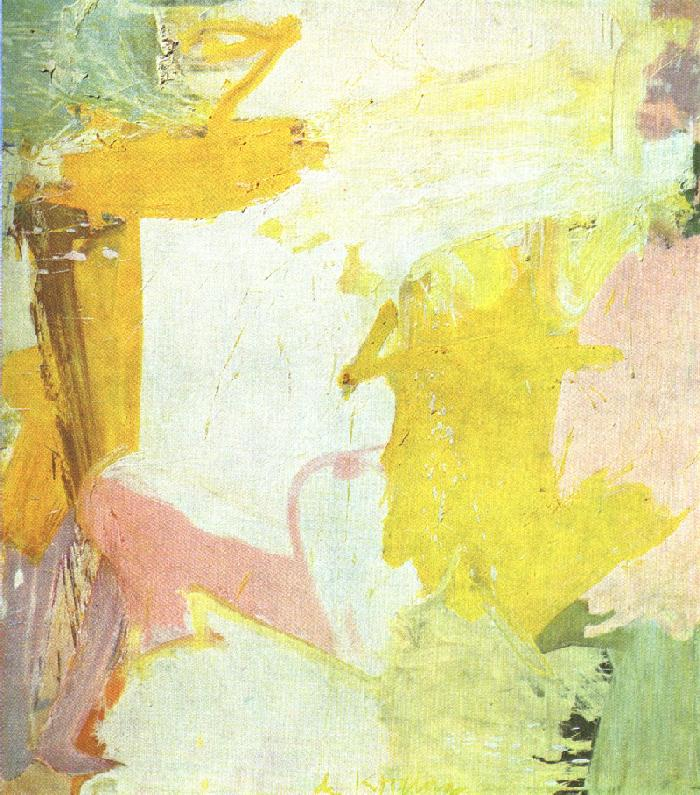Describe a story or scene that this painting might represent. Imagine a whimsical, ethereal garden at dawn. The first light of day casts soft hues of yellow and pink across the sky and landscape. Flowers and foliage, blurred in the morning mist, create a tapestry of abstract shapes and colors. The serenity of this garden is interrupted only by the gentle flutter of wings as mythical creatures, barely visible, flit from one abstract bloom to another. This painting could represent the fleeting, dreamlike transition from night to day in an enchanted realm, where reality and imagination blend seamlessly. 